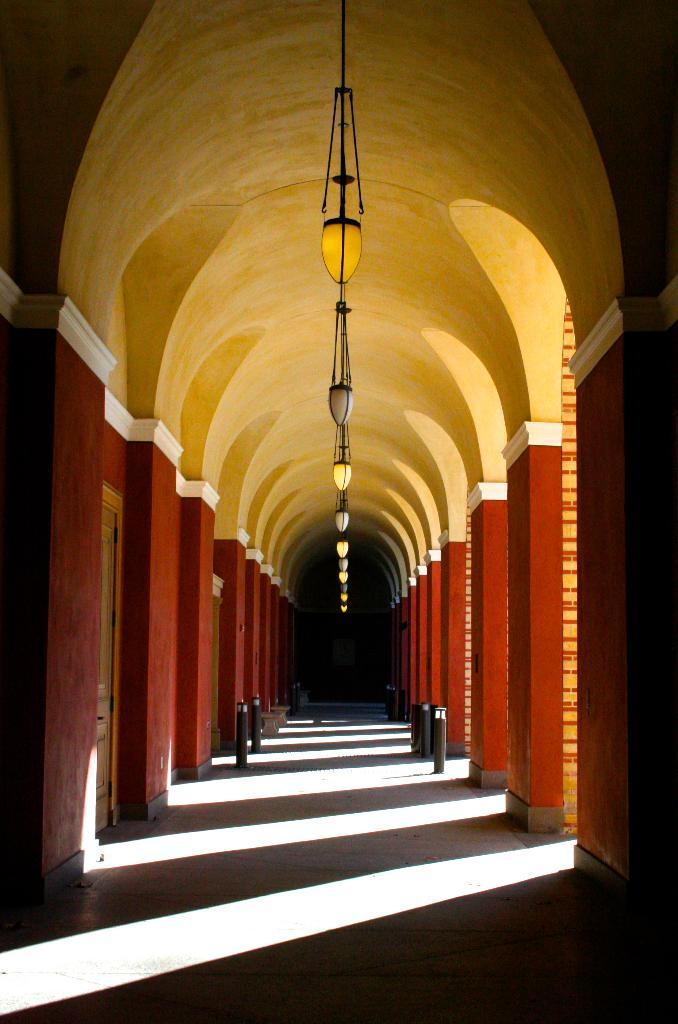What architectural features can be seen on both sides of the image? There are pillars on both the right and left sides of the image. What can be found within the structure depicted in the image? There are doors in the image. What objects are present in the image that are used for support or suspension? There are rods in the image. What can be seen at the top of the image? There are ropes and lights at the top of the image. What surface is visible at the bottom of the image? There is a floor visible at the bottom of the image. How many knees are visible in the image? There are no knees visible in the image. What type of crowd can be seen gathering around the structure in the image? There is no crowd present in the image; it only shows the structure and its components. 